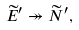Convert formula to latex. <formula><loc_0><loc_0><loc_500><loc_500>\widetilde { E } ^ { \prime } \twoheadrightarrow \widetilde { N } ^ { \prime } ,</formula> 